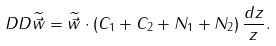<formula> <loc_0><loc_0><loc_500><loc_500>\ D D \widetilde { \vec { w } } = \widetilde { \vec { w } } \cdot \left ( C _ { 1 } + C _ { 2 } + N _ { 1 } + N _ { 2 } \right ) \frac { d z } { z } .</formula> 